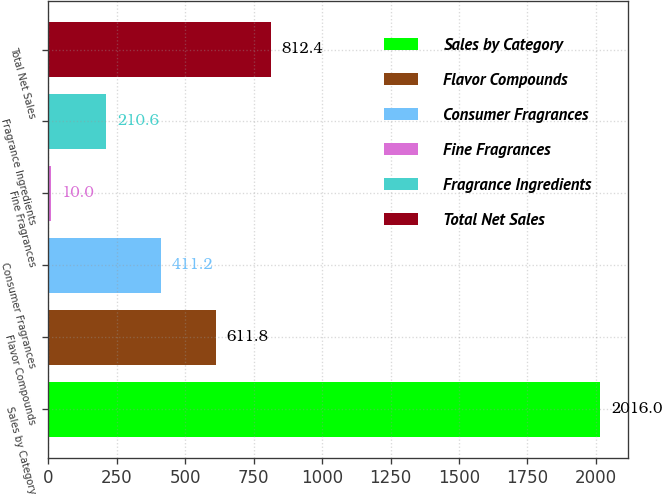Convert chart to OTSL. <chart><loc_0><loc_0><loc_500><loc_500><bar_chart><fcel>Sales by Category<fcel>Flavor Compounds<fcel>Consumer Fragrances<fcel>Fine Fragrances<fcel>Fragrance Ingredients<fcel>Total Net Sales<nl><fcel>2016<fcel>611.8<fcel>411.2<fcel>10<fcel>210.6<fcel>812.4<nl></chart> 